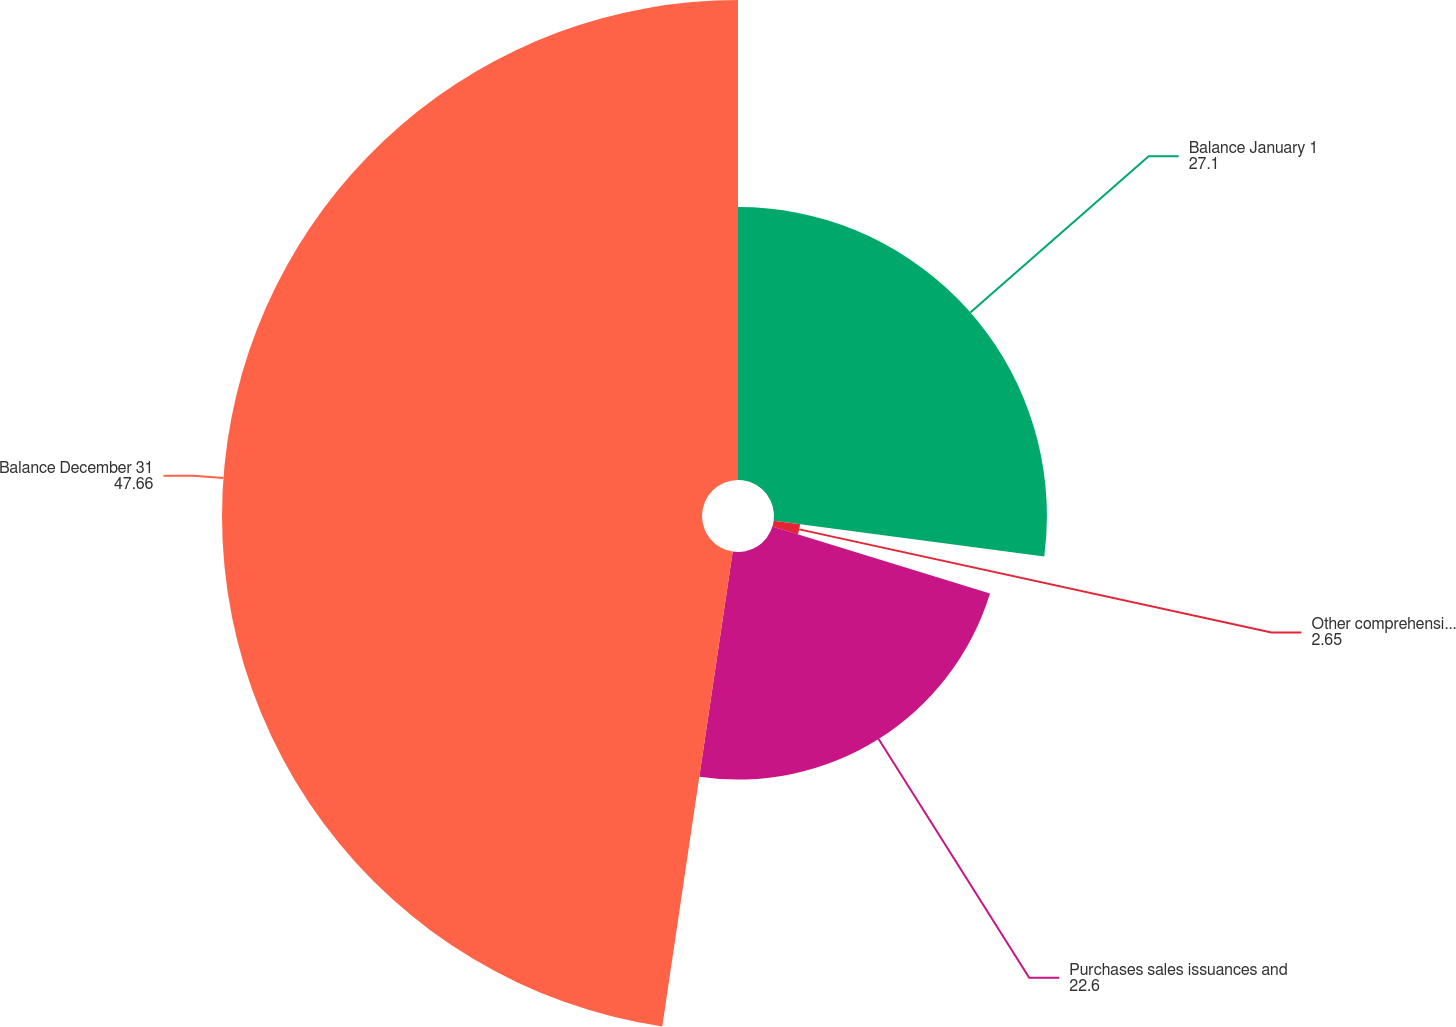Convert chart to OTSL. <chart><loc_0><loc_0><loc_500><loc_500><pie_chart><fcel>Balance January 1<fcel>Other comprehensive income<fcel>Purchases sales issuances and<fcel>Balance December 31<nl><fcel>27.1%<fcel>2.65%<fcel>22.6%<fcel>47.66%<nl></chart> 